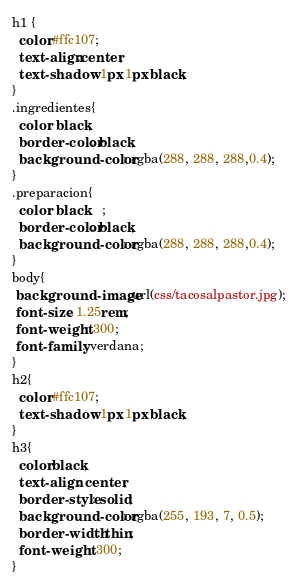<code> <loc_0><loc_0><loc_500><loc_500><_CSS_>h1 {
  color:#ffc107;
  text-align:center;
  text-shadow: 1px 1px black;
}
.ingredientes{
  color: black;
  border-color: black;
  background-color: rgba(288, 288, 288,0.4);
}
.preparacion{
  color: black	;
  border-color: black;
  background-color: rgba(288, 288, 288,0.4);
}
body{
 background-image:url(css/tacosalpastor.jpg);
 font-size: 1.25rem;
 font-weight: 300;
 font-family: verdana;
}
h2{
  color:#ffc107;
  text-shadow: 1px 1px black;
}
h3{
  color:black;
  text-align: center;
  border-style: solid;
  background-color: rgba(255, 193, 7, 0.5);
  border-width: thin;
  font-weight: 300;
}
</code> 